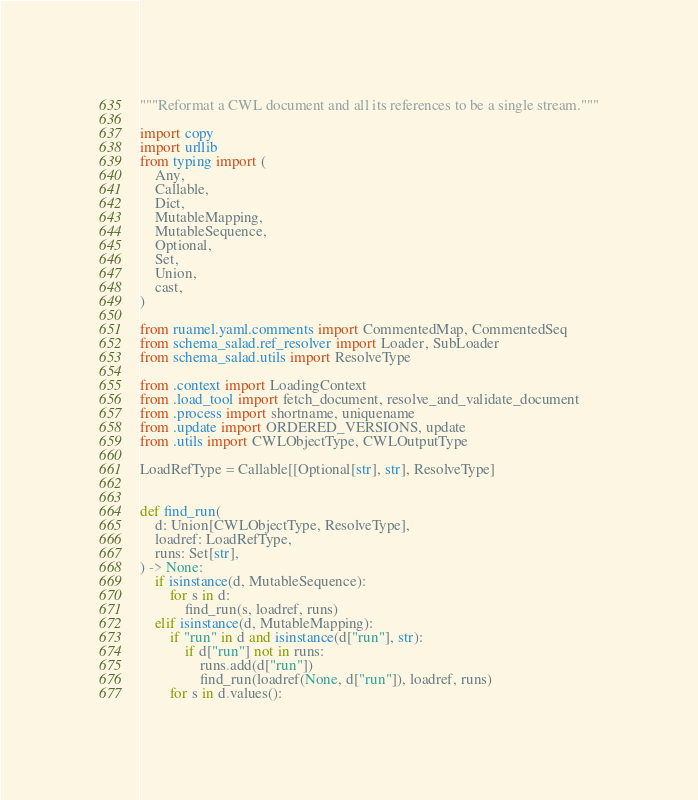Convert code to text. <code><loc_0><loc_0><loc_500><loc_500><_Python_>"""Reformat a CWL document and all its references to be a single stream."""

import copy
import urllib
from typing import (
    Any,
    Callable,
    Dict,
    MutableMapping,
    MutableSequence,
    Optional,
    Set,
    Union,
    cast,
)

from ruamel.yaml.comments import CommentedMap, CommentedSeq
from schema_salad.ref_resolver import Loader, SubLoader
from schema_salad.utils import ResolveType

from .context import LoadingContext
from .load_tool import fetch_document, resolve_and_validate_document
from .process import shortname, uniquename
from .update import ORDERED_VERSIONS, update
from .utils import CWLObjectType, CWLOutputType

LoadRefType = Callable[[Optional[str], str], ResolveType]


def find_run(
    d: Union[CWLObjectType, ResolveType],
    loadref: LoadRefType,
    runs: Set[str],
) -> None:
    if isinstance(d, MutableSequence):
        for s in d:
            find_run(s, loadref, runs)
    elif isinstance(d, MutableMapping):
        if "run" in d and isinstance(d["run"], str):
            if d["run"] not in runs:
                runs.add(d["run"])
                find_run(loadref(None, d["run"]), loadref, runs)
        for s in d.values():</code> 